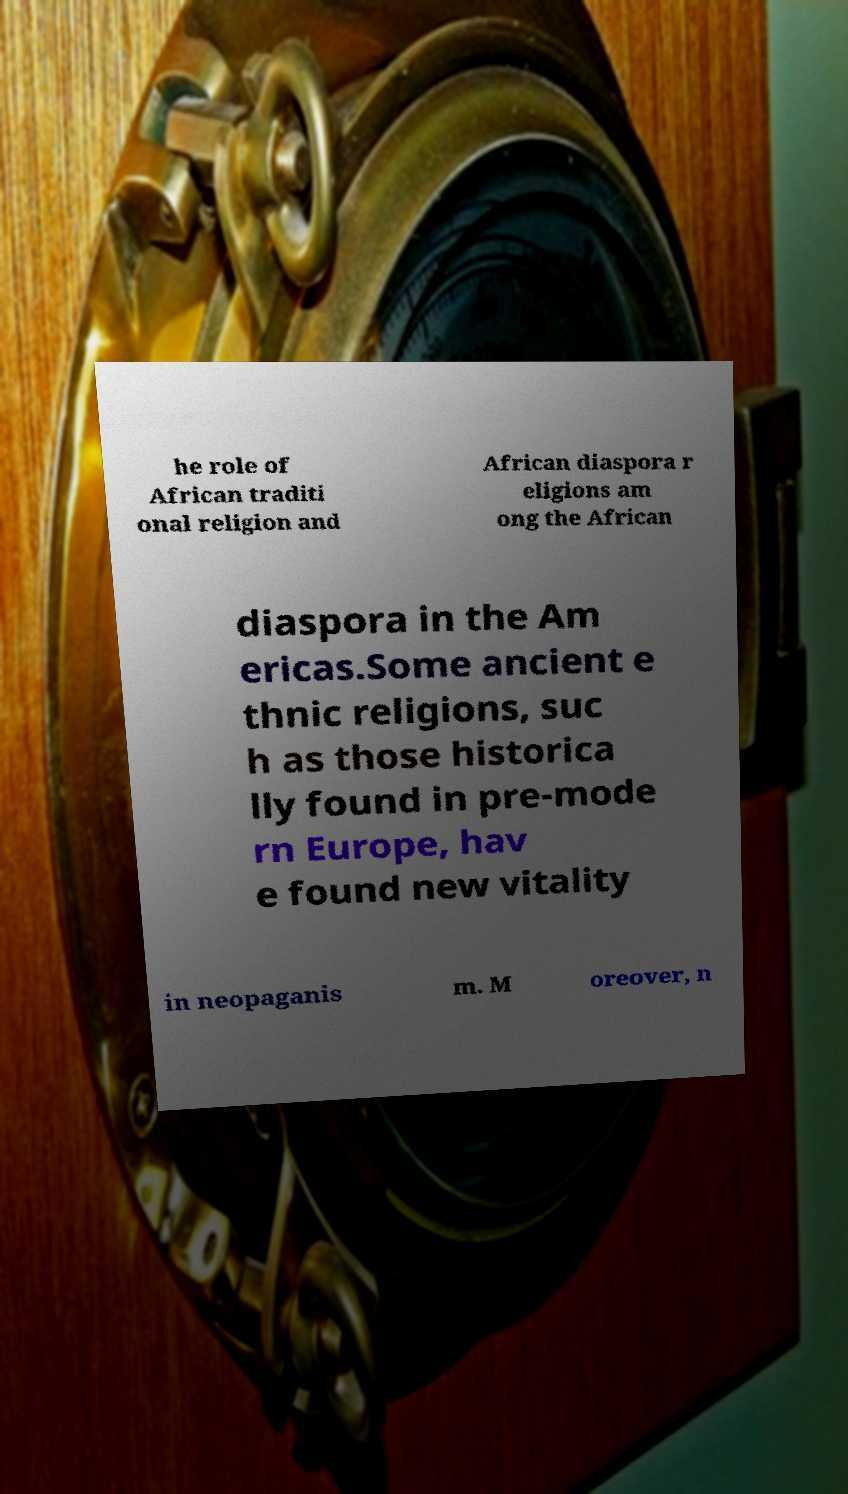Please identify and transcribe the text found in this image. he role of African traditi onal religion and African diaspora r eligions am ong the African diaspora in the Am ericas.Some ancient e thnic religions, suc h as those historica lly found in pre-mode rn Europe, hav e found new vitality in neopaganis m. M oreover, n 